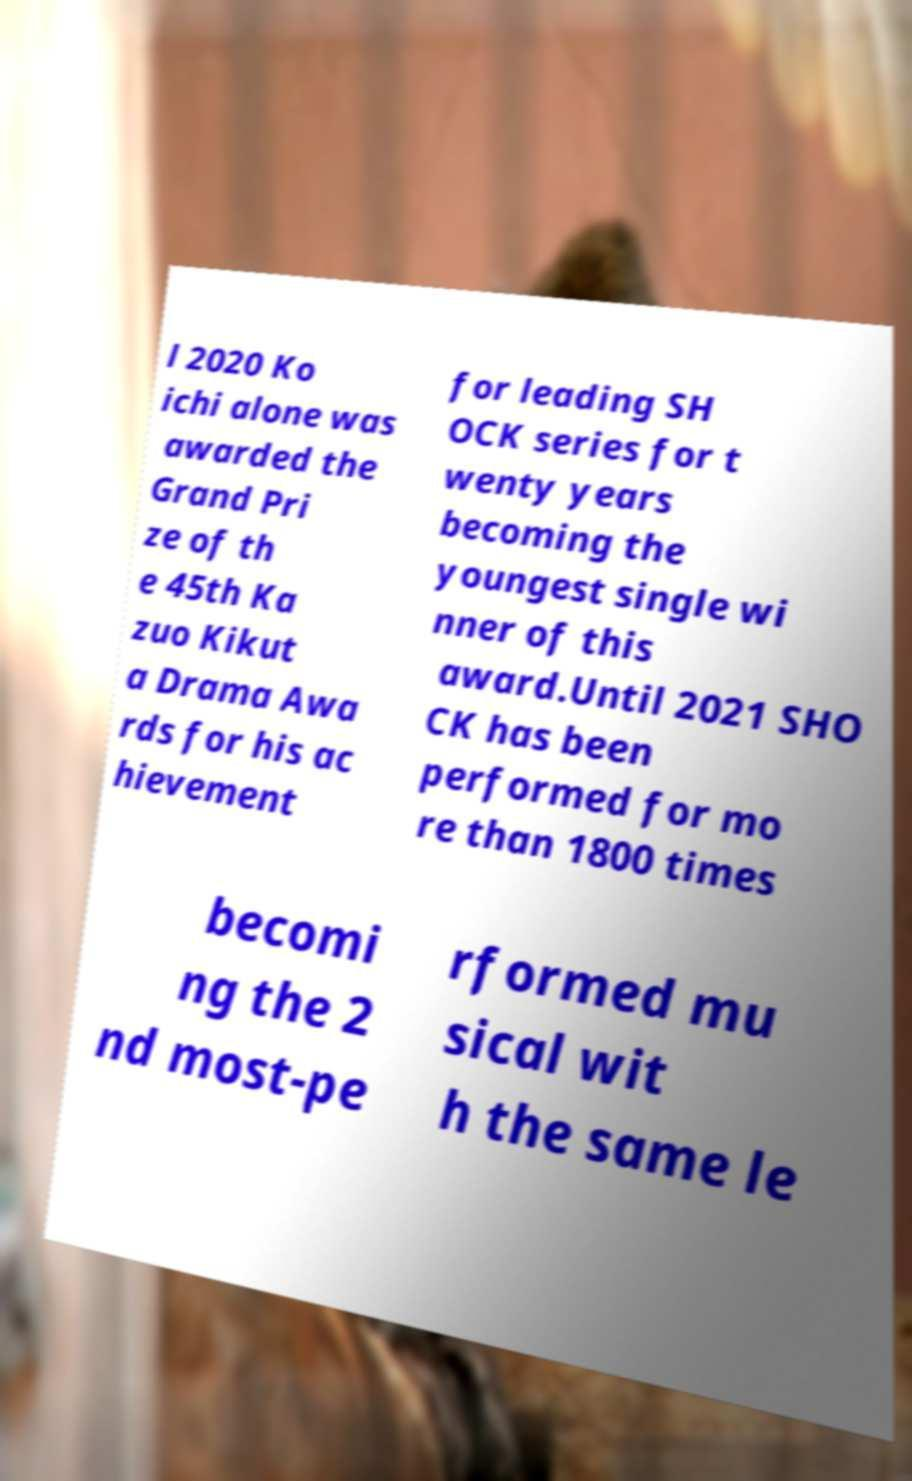I need the written content from this picture converted into text. Can you do that? l 2020 Ko ichi alone was awarded the Grand Pri ze of th e 45th Ka zuo Kikut a Drama Awa rds for his ac hievement for leading SH OCK series for t wenty years becoming the youngest single wi nner of this award.Until 2021 SHO CK has been performed for mo re than 1800 times becomi ng the 2 nd most-pe rformed mu sical wit h the same le 